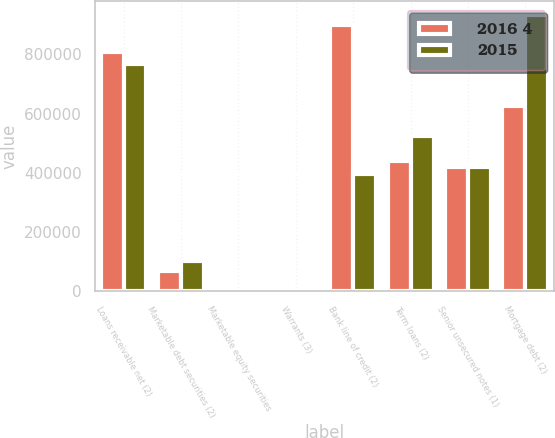Convert chart to OTSL. <chart><loc_0><loc_0><loc_500><loc_500><stacked_bar_chart><ecel><fcel>Loans receivable net (2)<fcel>Marketable debt securities (2)<fcel>Marketable equity securities<fcel>Warrants (3)<fcel>Bank line of credit (2)<fcel>Term loans (2)<fcel>Senior unsecured notes (1)<fcel>Mortgage debt (2)<nl><fcel>2016 4<fcel>807954<fcel>68630<fcel>76<fcel>19<fcel>899718<fcel>440062<fcel>418747<fcel>623792<nl><fcel>2015<fcel>768743<fcel>102958<fcel>39<fcel>55<fcel>397432<fcel>524807<fcel>418747<fcel>932212<nl></chart> 